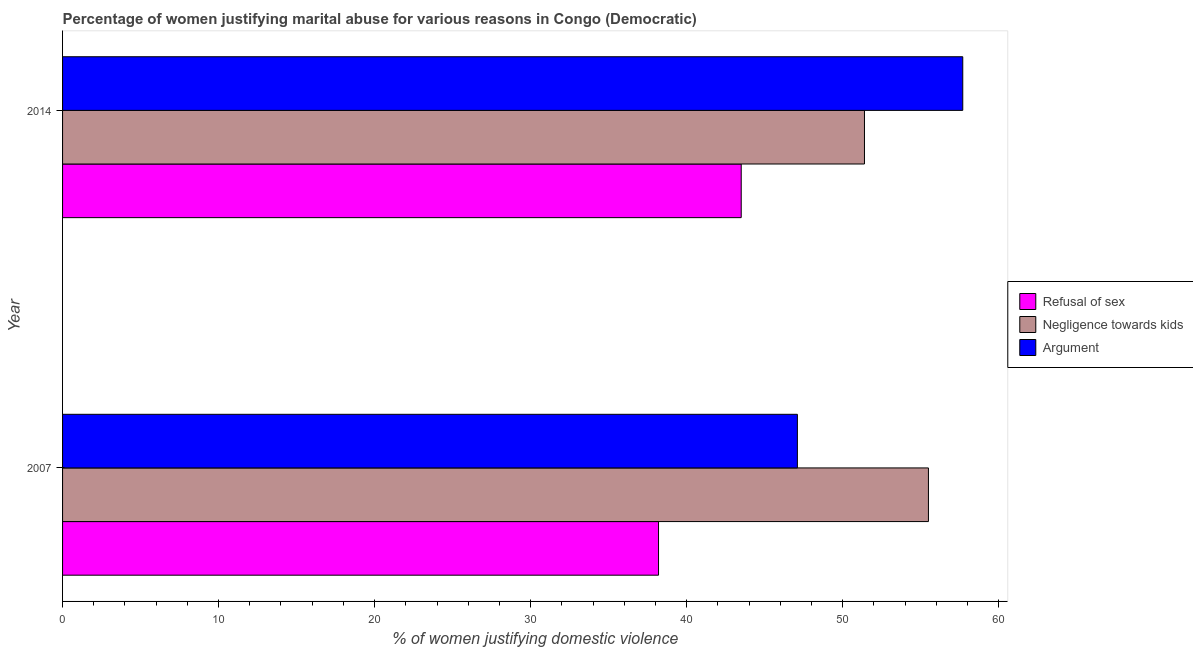How many groups of bars are there?
Offer a terse response. 2. Are the number of bars per tick equal to the number of legend labels?
Ensure brevity in your answer.  Yes. How many bars are there on the 1st tick from the bottom?
Ensure brevity in your answer.  3. In how many cases, is the number of bars for a given year not equal to the number of legend labels?
Your answer should be compact. 0. What is the percentage of women justifying domestic violence due to refusal of sex in 2007?
Your answer should be compact. 38.2. Across all years, what is the maximum percentage of women justifying domestic violence due to arguments?
Your response must be concise. 57.7. Across all years, what is the minimum percentage of women justifying domestic violence due to refusal of sex?
Give a very brief answer. 38.2. What is the total percentage of women justifying domestic violence due to negligence towards kids in the graph?
Offer a terse response. 106.9. What is the difference between the percentage of women justifying domestic violence due to negligence towards kids in 2007 and the percentage of women justifying domestic violence due to refusal of sex in 2014?
Provide a short and direct response. 12. What is the average percentage of women justifying domestic violence due to negligence towards kids per year?
Your answer should be very brief. 53.45. In the year 2007, what is the difference between the percentage of women justifying domestic violence due to negligence towards kids and percentage of women justifying domestic violence due to refusal of sex?
Keep it short and to the point. 17.3. In how many years, is the percentage of women justifying domestic violence due to arguments greater than 20 %?
Ensure brevity in your answer.  2. What is the ratio of the percentage of women justifying domestic violence due to refusal of sex in 2007 to that in 2014?
Keep it short and to the point. 0.88. Is the percentage of women justifying domestic violence due to refusal of sex in 2007 less than that in 2014?
Keep it short and to the point. Yes. What does the 1st bar from the top in 2007 represents?
Ensure brevity in your answer.  Argument. What does the 1st bar from the bottom in 2007 represents?
Provide a short and direct response. Refusal of sex. Is it the case that in every year, the sum of the percentage of women justifying domestic violence due to refusal of sex and percentage of women justifying domestic violence due to negligence towards kids is greater than the percentage of women justifying domestic violence due to arguments?
Your answer should be very brief. Yes. How many years are there in the graph?
Offer a very short reply. 2. What is the difference between two consecutive major ticks on the X-axis?
Your answer should be very brief. 10. Does the graph contain grids?
Offer a terse response. No. Where does the legend appear in the graph?
Ensure brevity in your answer.  Center right. How many legend labels are there?
Ensure brevity in your answer.  3. How are the legend labels stacked?
Offer a terse response. Vertical. What is the title of the graph?
Ensure brevity in your answer.  Percentage of women justifying marital abuse for various reasons in Congo (Democratic). Does "Natural gas sources" appear as one of the legend labels in the graph?
Give a very brief answer. No. What is the label or title of the X-axis?
Offer a very short reply. % of women justifying domestic violence. What is the % of women justifying domestic violence of Refusal of sex in 2007?
Keep it short and to the point. 38.2. What is the % of women justifying domestic violence in Negligence towards kids in 2007?
Make the answer very short. 55.5. What is the % of women justifying domestic violence of Argument in 2007?
Offer a terse response. 47.1. What is the % of women justifying domestic violence of Refusal of sex in 2014?
Give a very brief answer. 43.5. What is the % of women justifying domestic violence of Negligence towards kids in 2014?
Offer a very short reply. 51.4. What is the % of women justifying domestic violence of Argument in 2014?
Offer a terse response. 57.7. Across all years, what is the maximum % of women justifying domestic violence in Refusal of sex?
Keep it short and to the point. 43.5. Across all years, what is the maximum % of women justifying domestic violence of Negligence towards kids?
Make the answer very short. 55.5. Across all years, what is the maximum % of women justifying domestic violence in Argument?
Make the answer very short. 57.7. Across all years, what is the minimum % of women justifying domestic violence in Refusal of sex?
Give a very brief answer. 38.2. Across all years, what is the minimum % of women justifying domestic violence in Negligence towards kids?
Give a very brief answer. 51.4. Across all years, what is the minimum % of women justifying domestic violence of Argument?
Make the answer very short. 47.1. What is the total % of women justifying domestic violence in Refusal of sex in the graph?
Make the answer very short. 81.7. What is the total % of women justifying domestic violence in Negligence towards kids in the graph?
Offer a very short reply. 106.9. What is the total % of women justifying domestic violence of Argument in the graph?
Your answer should be compact. 104.8. What is the difference between the % of women justifying domestic violence of Refusal of sex in 2007 and that in 2014?
Your answer should be compact. -5.3. What is the difference between the % of women justifying domestic violence in Refusal of sex in 2007 and the % of women justifying domestic violence in Argument in 2014?
Provide a succinct answer. -19.5. What is the difference between the % of women justifying domestic violence of Negligence towards kids in 2007 and the % of women justifying domestic violence of Argument in 2014?
Give a very brief answer. -2.2. What is the average % of women justifying domestic violence of Refusal of sex per year?
Offer a terse response. 40.85. What is the average % of women justifying domestic violence in Negligence towards kids per year?
Make the answer very short. 53.45. What is the average % of women justifying domestic violence of Argument per year?
Keep it short and to the point. 52.4. In the year 2007, what is the difference between the % of women justifying domestic violence in Refusal of sex and % of women justifying domestic violence in Negligence towards kids?
Ensure brevity in your answer.  -17.3. In the year 2007, what is the difference between the % of women justifying domestic violence of Refusal of sex and % of women justifying domestic violence of Argument?
Offer a very short reply. -8.9. In the year 2014, what is the difference between the % of women justifying domestic violence of Refusal of sex and % of women justifying domestic violence of Negligence towards kids?
Ensure brevity in your answer.  -7.9. In the year 2014, what is the difference between the % of women justifying domestic violence in Negligence towards kids and % of women justifying domestic violence in Argument?
Provide a short and direct response. -6.3. What is the ratio of the % of women justifying domestic violence in Refusal of sex in 2007 to that in 2014?
Your answer should be compact. 0.88. What is the ratio of the % of women justifying domestic violence of Negligence towards kids in 2007 to that in 2014?
Provide a succinct answer. 1.08. What is the ratio of the % of women justifying domestic violence in Argument in 2007 to that in 2014?
Ensure brevity in your answer.  0.82. What is the difference between the highest and the second highest % of women justifying domestic violence in Negligence towards kids?
Your answer should be compact. 4.1. What is the difference between the highest and the lowest % of women justifying domestic violence of Argument?
Keep it short and to the point. 10.6. 